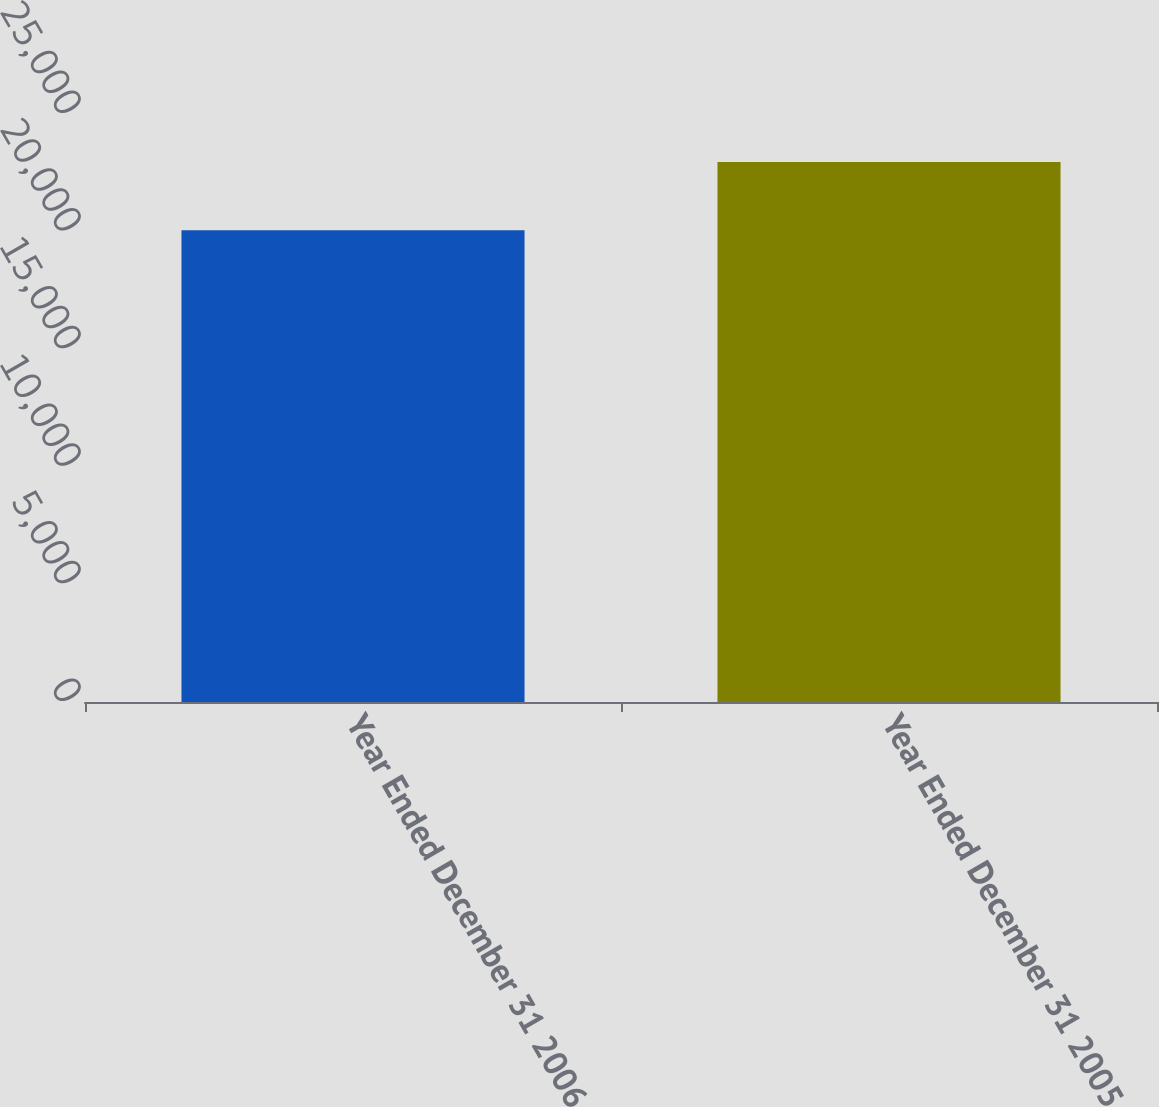Convert chart. <chart><loc_0><loc_0><loc_500><loc_500><bar_chart><fcel>Year Ended December 31 2006<fcel>Year Ended December 31 2005<nl><fcel>20061<fcel>22958<nl></chart> 